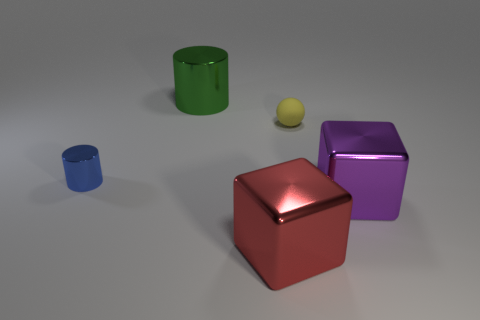Add 5 small rubber things. How many objects exist? 10 Subtract all brown matte spheres. Subtract all small cylinders. How many objects are left? 4 Add 4 red objects. How many red objects are left? 5 Add 4 blue matte objects. How many blue matte objects exist? 4 Subtract all purple blocks. How many blocks are left? 1 Subtract 1 red cubes. How many objects are left? 4 Subtract all balls. How many objects are left? 4 Subtract 1 cylinders. How many cylinders are left? 1 Subtract all brown spheres. Subtract all gray blocks. How many spheres are left? 1 